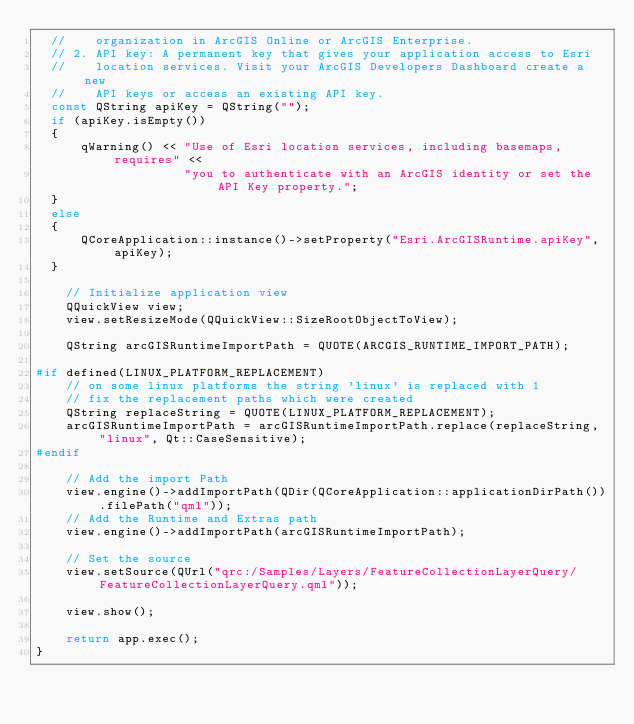<code> <loc_0><loc_0><loc_500><loc_500><_C++_>  //    organization in ArcGIS Online or ArcGIS Enterprise.
  // 2. API key: A permanent key that gives your application access to Esri
  //    location services. Visit your ArcGIS Developers Dashboard create a new
  //    API keys or access an existing API key.
  const QString apiKey = QString("");
  if (apiKey.isEmpty())
  {
      qWarning() << "Use of Esri location services, including basemaps, requires" <<
                    "you to authenticate with an ArcGIS identity or set the API Key property.";
  }
  else
  {
      QCoreApplication::instance()->setProperty("Esri.ArcGISRuntime.apiKey", apiKey);
  }

    // Initialize application view
    QQuickView view;
    view.setResizeMode(QQuickView::SizeRootObjectToView);

    QString arcGISRuntimeImportPath = QUOTE(ARCGIS_RUNTIME_IMPORT_PATH);

#if defined(LINUX_PLATFORM_REPLACEMENT)
    // on some linux platforms the string 'linux' is replaced with 1
    // fix the replacement paths which were created
    QString replaceString = QUOTE(LINUX_PLATFORM_REPLACEMENT);
    arcGISRuntimeImportPath = arcGISRuntimeImportPath.replace(replaceString, "linux", Qt::CaseSensitive);
#endif

    // Add the import Path
    view.engine()->addImportPath(QDir(QCoreApplication::applicationDirPath()).filePath("qml"));
    // Add the Runtime and Extras path
    view.engine()->addImportPath(arcGISRuntimeImportPath);

    // Set the source
    view.setSource(QUrl("qrc:/Samples/Layers/FeatureCollectionLayerQuery/FeatureCollectionLayerQuery.qml"));

    view.show();

    return app.exec();
}
</code> 